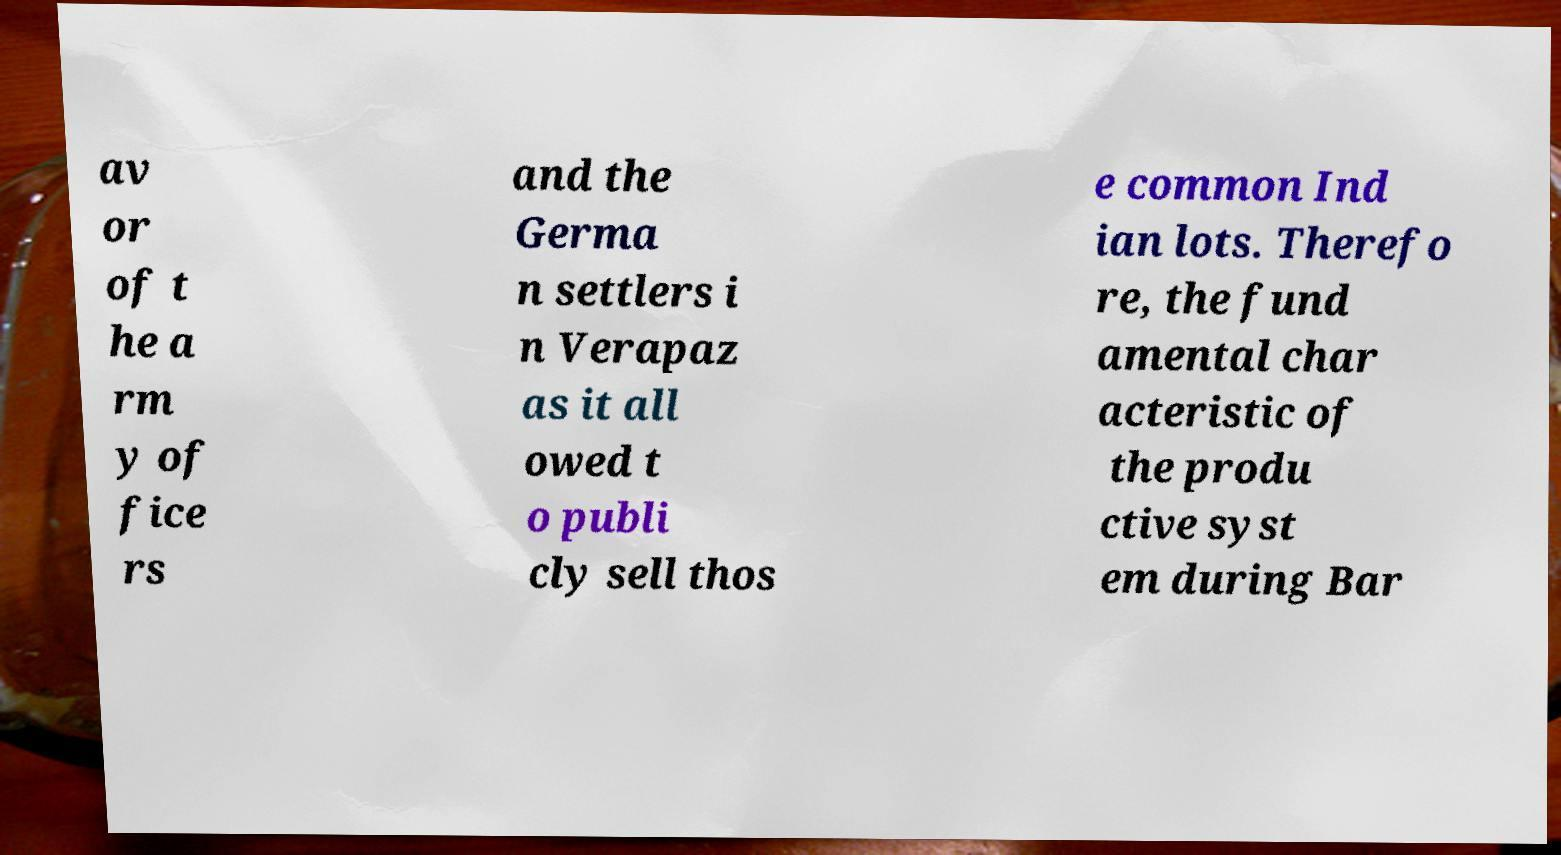There's text embedded in this image that I need extracted. Can you transcribe it verbatim? av or of t he a rm y of fice rs and the Germa n settlers i n Verapaz as it all owed t o publi cly sell thos e common Ind ian lots. Therefo re, the fund amental char acteristic of the produ ctive syst em during Bar 